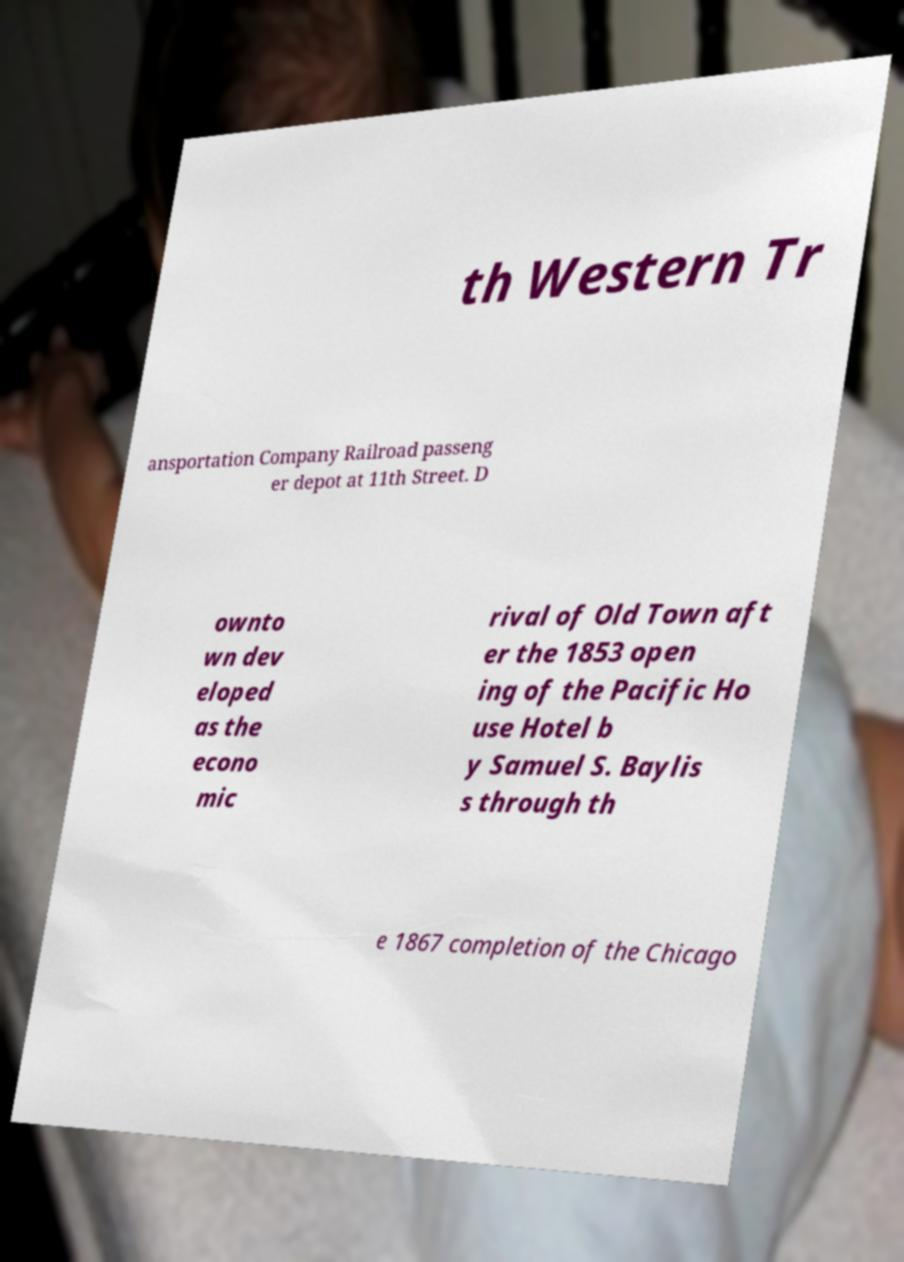Can you accurately transcribe the text from the provided image for me? th Western Tr ansportation Company Railroad passeng er depot at 11th Street. D ownto wn dev eloped as the econo mic rival of Old Town aft er the 1853 open ing of the Pacific Ho use Hotel b y Samuel S. Baylis s through th e 1867 completion of the Chicago 